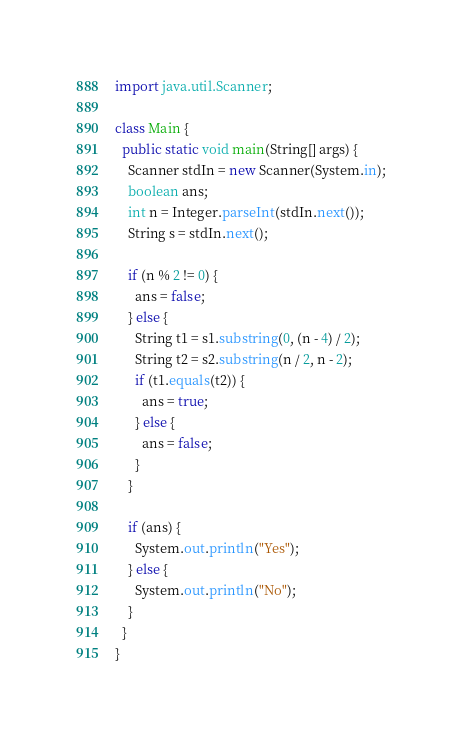Convert code to text. <code><loc_0><loc_0><loc_500><loc_500><_Java_>import java.util.Scanner;

class Main {
  public static void main(String[] args) {
    Scanner stdIn = new Scanner(System.in);
    boolean ans;
    int n = Integer.parseInt(stdIn.next());
    String s = stdIn.next();

    if (n % 2 != 0) {
      ans = false;
    } else {
      String t1 = s1.substring(0, (n - 4) / 2);
      String t2 = s2.substring(n / 2, n - 2);
      if (t1.equals(t2)) {
        ans = true;
      } else {
        ans = false;
      }
    }

    if (ans) {
      System.out.println("Yes");
    } else {
      System.out.println("No");
    }
  }
}
</code> 